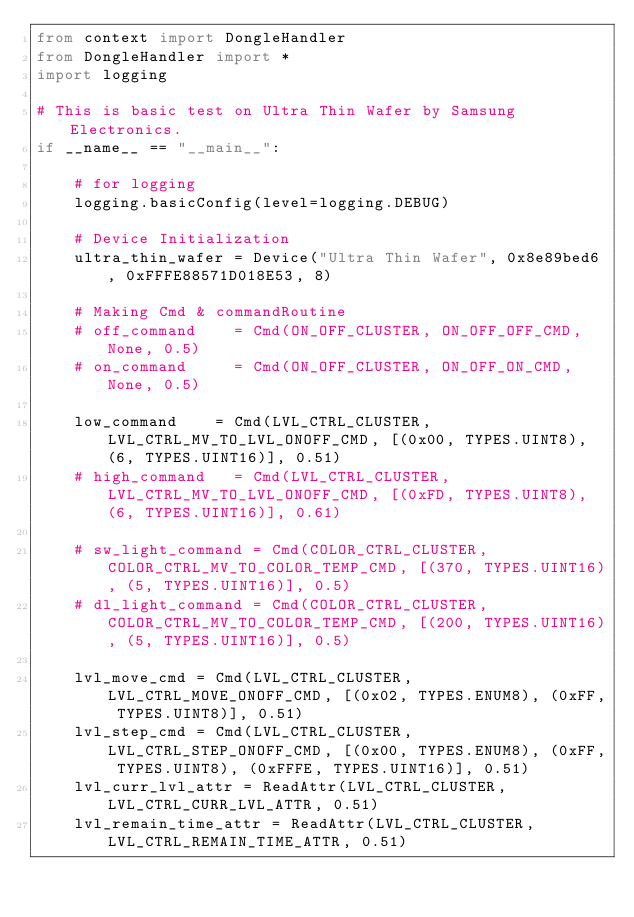<code> <loc_0><loc_0><loc_500><loc_500><_Python_>from context import DongleHandler
from DongleHandler import *
import logging

# This is basic test on Ultra Thin Wafer by Samsung Electronics.
if __name__ == "__main__":

    # for logging
    logging.basicConfig(level=logging.DEBUG)

    # Device Initialization
    ultra_thin_wafer = Device("Ultra Thin Wafer", 0x8e89bed6, 0xFFFE88571D018E53, 8)

    # Making Cmd & commandRoutine
    # off_command    = Cmd(ON_OFF_CLUSTER, ON_OFF_OFF_CMD, None, 0.5)
    # on_command     = Cmd(ON_OFF_CLUSTER, ON_OFF_ON_CMD, None, 0.5)

    low_command    = Cmd(LVL_CTRL_CLUSTER, LVL_CTRL_MV_TO_LVL_ONOFF_CMD, [(0x00, TYPES.UINT8), (6, TYPES.UINT16)], 0.51)
    # high_command   = Cmd(LVL_CTRL_CLUSTER, LVL_CTRL_MV_TO_LVL_ONOFF_CMD, [(0xFD, TYPES.UINT8), (6, TYPES.UINT16)], 0.61)

    # sw_light_command = Cmd(COLOR_CTRL_CLUSTER, COLOR_CTRL_MV_TO_COLOR_TEMP_CMD, [(370, TYPES.UINT16), (5, TYPES.UINT16)], 0.5)
    # dl_light_command = Cmd(COLOR_CTRL_CLUSTER, COLOR_CTRL_MV_TO_COLOR_TEMP_CMD, [(200, TYPES.UINT16), (5, TYPES.UINT16)], 0.5)

    lvl_move_cmd = Cmd(LVL_CTRL_CLUSTER, LVL_CTRL_MOVE_ONOFF_CMD, [(0x02, TYPES.ENUM8), (0xFF, TYPES.UINT8)], 0.51)
    lvl_step_cmd = Cmd(LVL_CTRL_CLUSTER, LVL_CTRL_STEP_ONOFF_CMD, [(0x00, TYPES.ENUM8), (0xFF, TYPES.UINT8), (0xFFFE, TYPES.UINT16)], 0.51)
    lvl_curr_lvl_attr = ReadAttr(LVL_CTRL_CLUSTER, LVL_CTRL_CURR_LVL_ATTR, 0.51)
    lvl_remain_time_attr = ReadAttr(LVL_CTRL_CLUSTER, LVL_CTRL_REMAIN_TIME_ATTR, 0.51)
</code> 